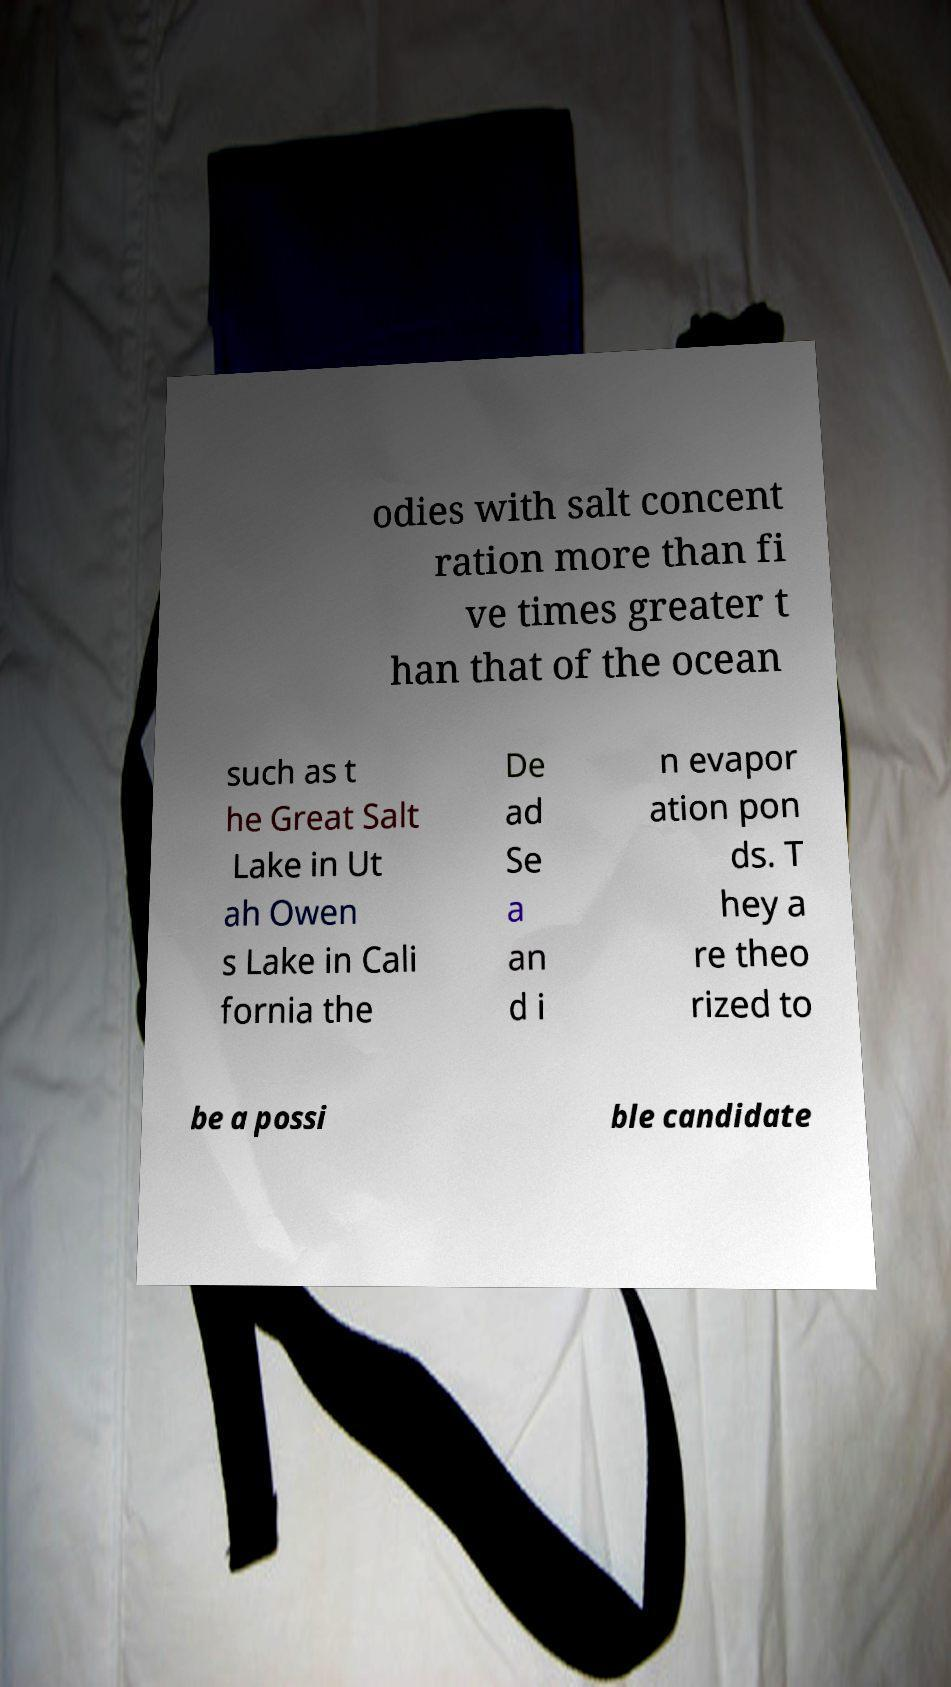What messages or text are displayed in this image? I need them in a readable, typed format. odies with salt concent ration more than fi ve times greater t han that of the ocean such as t he Great Salt Lake in Ut ah Owen s Lake in Cali fornia the De ad Se a an d i n evapor ation pon ds. T hey a re theo rized to be a possi ble candidate 